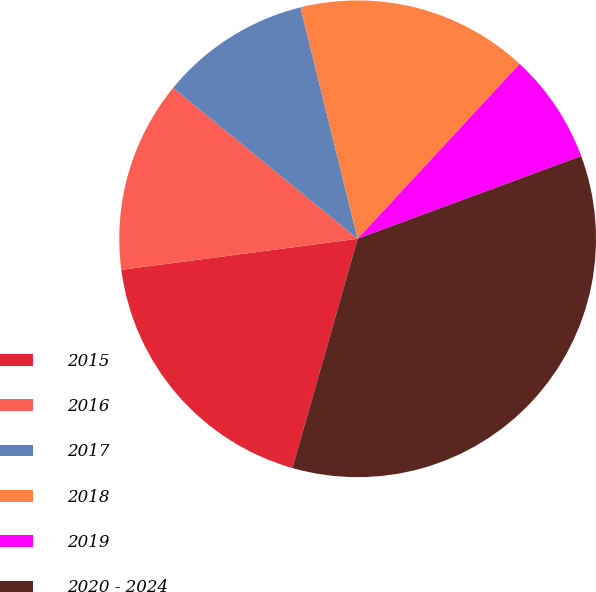Convert chart. <chart><loc_0><loc_0><loc_500><loc_500><pie_chart><fcel>2015<fcel>2016<fcel>2017<fcel>2018<fcel>2019<fcel>2020 - 2024<nl><fcel>18.51%<fcel>12.99%<fcel>10.23%<fcel>15.75%<fcel>7.47%<fcel>35.05%<nl></chart> 